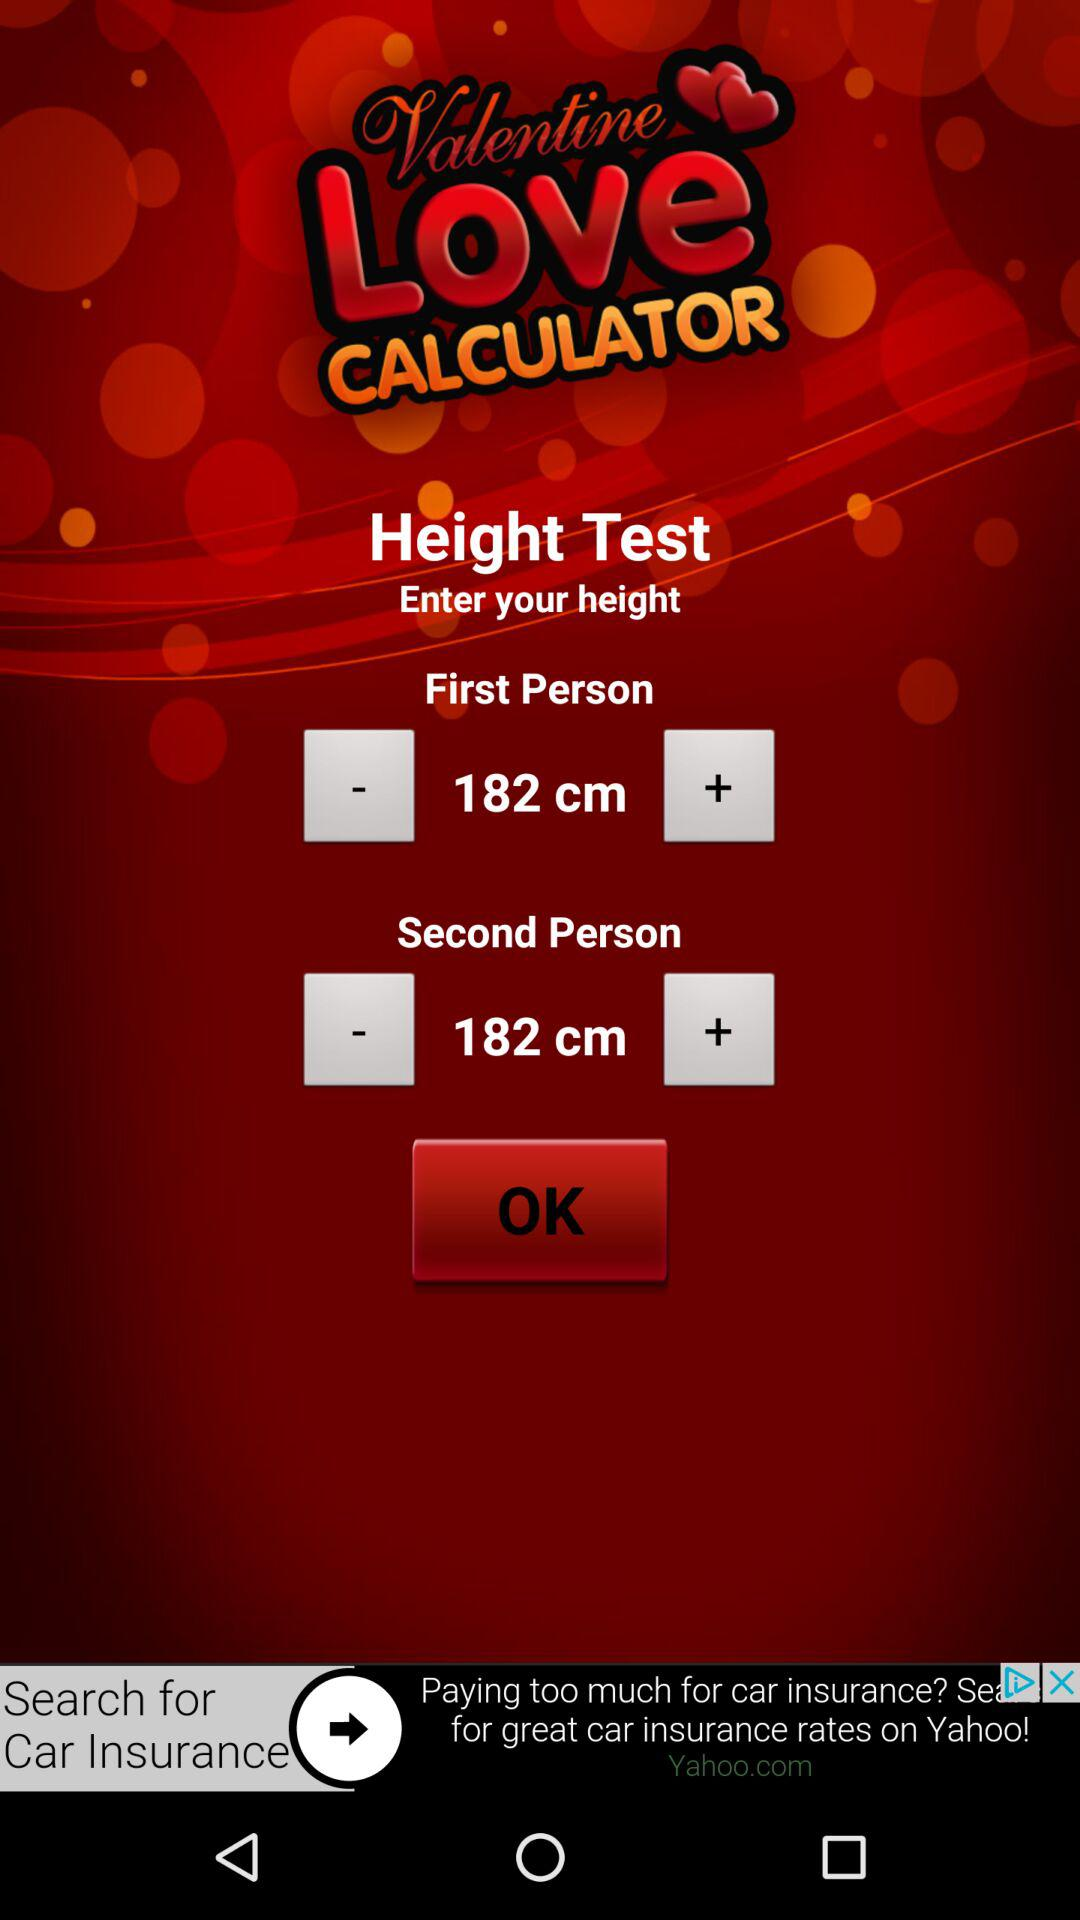What is the application name? The application name is "Valentine Love CALCULATOR". 